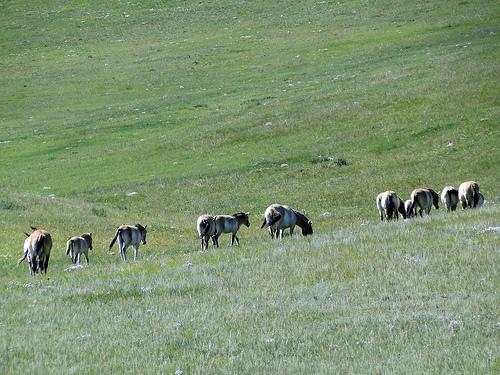Identify the significant elements in this picture and their interplay. Animals, possibly sheep, grazing in an expansive field with scattered rocks among the short grass, giving a serene view of nature during the afternoon hours. Describe the environment and time of day portrayed in the image. The image showcases a large field with short green grass, rocks, and grazing animals, evidently taken during the afternoon. What are the sheep in the image doing and what is their appearance? The sheep are grazing in a field, primarily brown and black in color with some white markings, and walking in one direction. Determining the colors and conditions of the rocks displayed within the image. The rocks in the picture are gray in color, casually dispersed around the field, harmonizing with the surroundings. What is the visual sentiment of this image based on the elements and their natural interaction? The sentiment of the image exudes tranquility, as the scene depicts animals peacefully grazing in a large field amidst green grass and rocks. Quantify the number of sheep that are either brown or black and are standing in the grassy field eating. At least ten sheep, both brown and black, are standing in the grassy field eating or grazing. What are the evident features of the sheep's tails and legs in the image? The tails of the animals are short and fluffy, while their legs appear to be short and sturdy. Relate the condition and attributes of the field in which the animals are situated. The grazing field is vast, with short green grass, and contains some gray rocks dispersed throughout. Explain the likely main subject of the image based on object sizes and their positioning in the field. The most probable main subject of the image is the grazing animals, particularly the sheep, since they cover a larger part of the field and are interacting directly with their environment. Briefly state the primary objects in the image and their activity. Animals are grazing in a large field with rocks and green grass, mostly brown and black with some white markings, in the afternoon. 